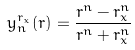<formula> <loc_0><loc_0><loc_500><loc_500>y _ { n } ^ { r _ { x } } ( r ) = \frac { r ^ { n } - r _ { x } ^ { n } } { r ^ { n } + r _ { x } ^ { n } }</formula> 